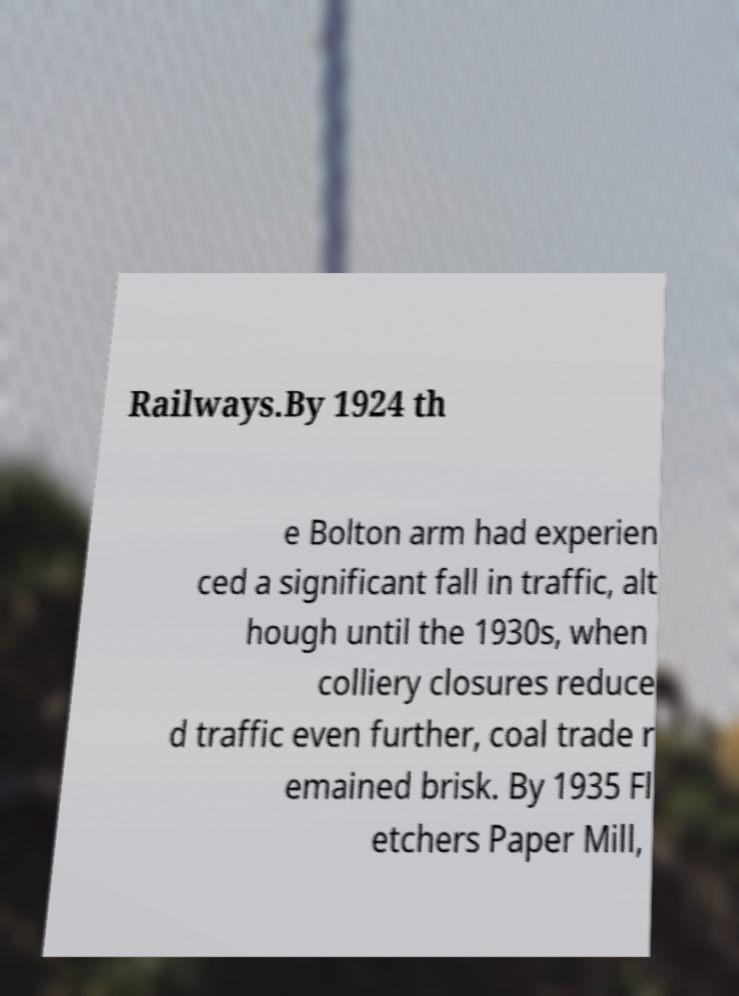Could you extract and type out the text from this image? Railways.By 1924 th e Bolton arm had experien ced a significant fall in traffic, alt hough until the 1930s, when colliery closures reduce d traffic even further, coal trade r emained brisk. By 1935 Fl etchers Paper Mill, 